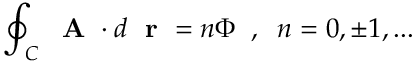<formula> <loc_0><loc_0><loc_500><loc_500>\oint _ { C } A \cdot d r = n \Phi \, , \, n = 0 , \pm 1 , \dots</formula> 